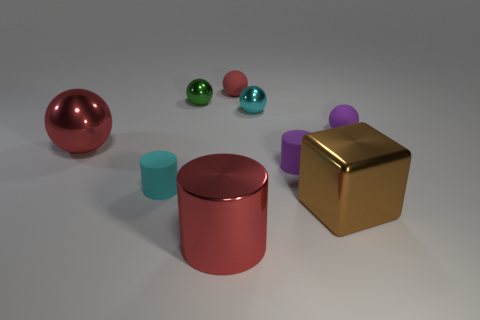Subtract all small cyan balls. How many balls are left? 4 Subtract all purple balls. How many balls are left? 4 Subtract all brown balls. Subtract all purple blocks. How many balls are left? 5 Add 1 brown shiny objects. How many objects exist? 10 Subtract all blocks. How many objects are left? 8 Add 2 tiny shiny things. How many tiny shiny things are left? 4 Add 1 balls. How many balls exist? 6 Subtract 0 purple cubes. How many objects are left? 9 Subtract all big brown things. Subtract all green balls. How many objects are left? 7 